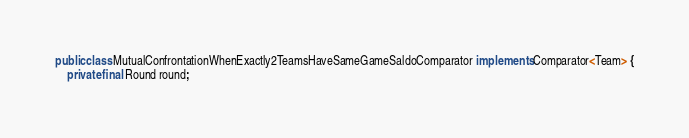Convert code to text. <code><loc_0><loc_0><loc_500><loc_500><_Java_>
public class MutualConfrontationWhenExactly2TeamsHaveSameGameSaldoComparator implements Comparator<Team> {
    private final Round round;</code> 